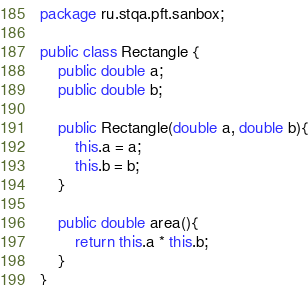<code> <loc_0><loc_0><loc_500><loc_500><_Java_>package ru.stqa.pft.sanbox;

public class Rectangle {
    public double a;
    public double b;

    public Rectangle(double a, double b){
        this.a = a;
        this.b = b;
    }

    public double area(){
        return this.a * this.b;
    }
}
</code> 